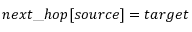<formula> <loc_0><loc_0><loc_500><loc_500>n e x t \text  underscore h o p [ s o u r c e ] = t \arg e t</formula> 